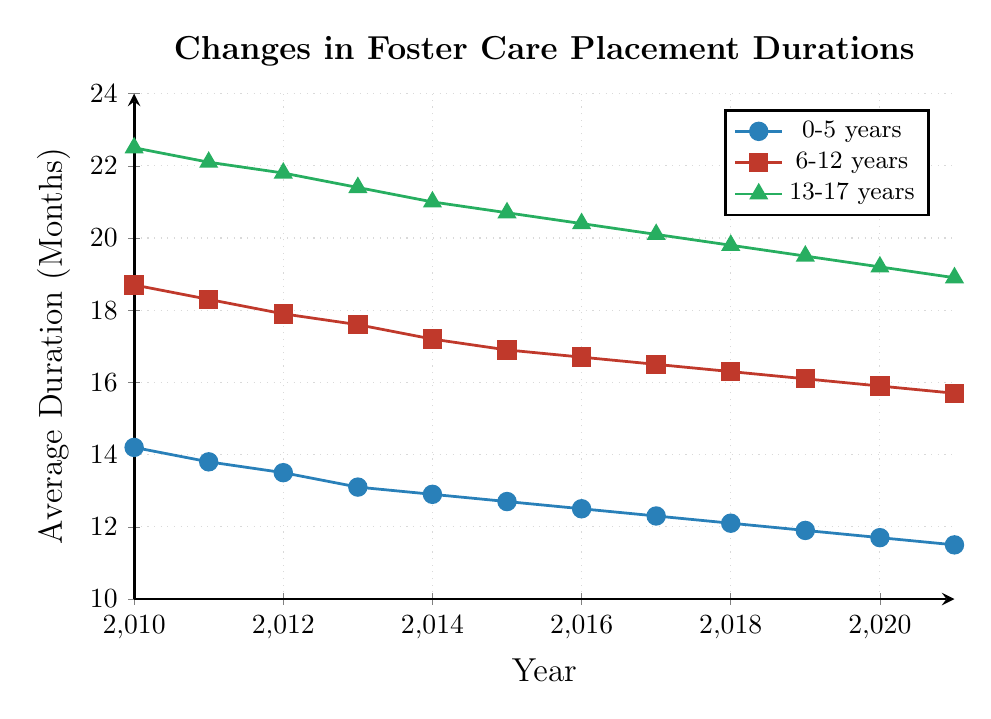What's the average duration of foster care placements for the 0-5 years age group in 2010 and 2021? First, find the placements for 2010 and 2021 in the 0-5 years age group which are 14.2 months and 11.5 months respectively. Then, calculate the average by summing these values and dividing by 2: (14.2 + 11.5) / 2 = 12.85
Answer: 12.85 Which age group experienced the largest decrease in foster care placement duration from 2010 to 2021? Compare the decrease for each age group by subtracting the 2021 values from the 2010 values. For 0-5 years: 14.2 - 11.5 = 2.7, for 6-12 years: 18.7 - 15.7 = 3.0, for 13-17 years: 22.5 - 18.9 = 3.6. The largest decrease is in the 13-17 years group.
Answer: 13-17 years In what year did the average duration of foster care placements first drop below 20 months for the 13-17 years age group? Examine the plotted points for the 13-17 years age group line, and find that in 2018 the duration is 19.8 months, which is the first time it drops below 20 months.
Answer: 2018 How did the average foster care placement duration change over time for the 6-12 years age group? Observing the 6-12 years line, it starts at 18.7 in 2010 and steadily decreases each year, reaching 15.7 in 2021, showing a consistent downward trend.
Answer: Consistent decrease Between 2015 and 2017, which age group's foster care placement duration decreased the most? Calculate the difference for each age group between 2015 and 2017. For 0-5 years: 12.7 - 12.3 = 0.4, for 6-12 years: 16.9 - 16.5 = 0.4, for 13-17 years: 20.7 - 20.1 = 0.6. The 13-17 years age group had the largest decrease.
Answer: 13-17 years What is the overall trend in average foster care placement duration for all age groups from 2010 to 2021? Reviewing the lines for all three age groups, each line shows a generally steady downward slope from 2010 to 2021, indicating an overall decrease in placement durations over time.
Answer: Downward trend Which age group had the smallest decline in foster care placement duration from 2010 to 2021? Calculate the total decline for each group from 2010 to 2021. For 0-5 years: 14.2 - 11.5 = 2.7, for 6-12 years: 18.7 - 15.7 = 3.0, for 13-17 years: 22.5 - 18.9 = 3.6. The smallest decline is in the 0-5 years group.
Answer: 0-5 years In which year did the 6-12 years age group experience the largest year-over-year drop in foster care placement duration? Look at the year-over-year changes in the 6-12 years data points and find that the largest drop is between 2014 (17.2) and 2015 (16.9), which is 0.3 months.
Answer: 2014-2015 Which age group consistently had the longest average foster care placement duration from 2010 to 2021? Compare the lines visually, and note that the 13-17 years age group is consistently above the other two groups throughout the entire time period.
Answer: 13-17 years By how much did the average foster care placement duration for the 0-5 years age group decrease from 2011 to 2016? Compute the difference between the 2011 and 2016 values in the 0-5 years group: 13.8 - 12.5 = 1.3 months.
Answer: 1.3 